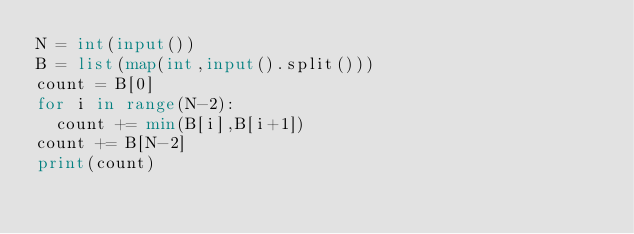Convert code to text. <code><loc_0><loc_0><loc_500><loc_500><_Python_>N = int(input())
B = list(map(int,input().split()))
count = B[0]
for i in range(N-2):
  count += min(B[i],B[i+1])
count += B[N-2]
print(count)</code> 